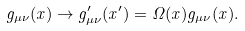<formula> <loc_0><loc_0><loc_500><loc_500>g _ { \mu \nu } ( x ) \rightarrow g _ { \mu \nu } ^ { \prime } ( x ^ { \prime } ) = \Omega ( x ) g _ { \mu \nu } ( x ) .</formula> 